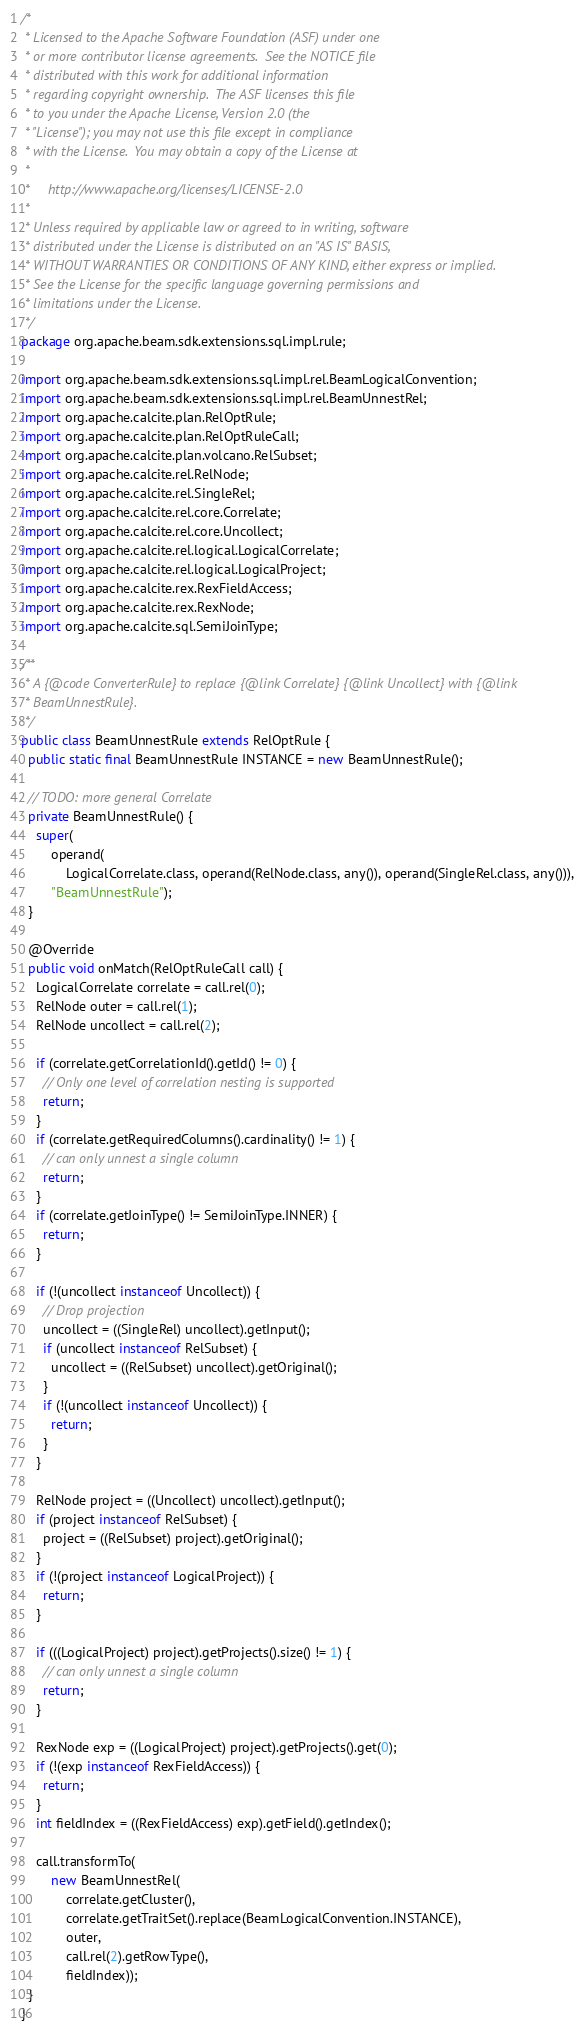<code> <loc_0><loc_0><loc_500><loc_500><_Java_>/*
 * Licensed to the Apache Software Foundation (ASF) under one
 * or more contributor license agreements.  See the NOTICE file
 * distributed with this work for additional information
 * regarding copyright ownership.  The ASF licenses this file
 * to you under the Apache License, Version 2.0 (the
 * "License"); you may not use this file except in compliance
 * with the License.  You may obtain a copy of the License at
 *
 *     http://www.apache.org/licenses/LICENSE-2.0
 *
 * Unless required by applicable law or agreed to in writing, software
 * distributed under the License is distributed on an "AS IS" BASIS,
 * WITHOUT WARRANTIES OR CONDITIONS OF ANY KIND, either express or implied.
 * See the License for the specific language governing permissions and
 * limitations under the License.
 */
package org.apache.beam.sdk.extensions.sql.impl.rule;

import org.apache.beam.sdk.extensions.sql.impl.rel.BeamLogicalConvention;
import org.apache.beam.sdk.extensions.sql.impl.rel.BeamUnnestRel;
import org.apache.calcite.plan.RelOptRule;
import org.apache.calcite.plan.RelOptRuleCall;
import org.apache.calcite.plan.volcano.RelSubset;
import org.apache.calcite.rel.RelNode;
import org.apache.calcite.rel.SingleRel;
import org.apache.calcite.rel.core.Correlate;
import org.apache.calcite.rel.core.Uncollect;
import org.apache.calcite.rel.logical.LogicalCorrelate;
import org.apache.calcite.rel.logical.LogicalProject;
import org.apache.calcite.rex.RexFieldAccess;
import org.apache.calcite.rex.RexNode;
import org.apache.calcite.sql.SemiJoinType;

/**
 * A {@code ConverterRule} to replace {@link Correlate} {@link Uncollect} with {@link
 * BeamUnnestRule}.
 */
public class BeamUnnestRule extends RelOptRule {
  public static final BeamUnnestRule INSTANCE = new BeamUnnestRule();

  // TODO: more general Correlate
  private BeamUnnestRule() {
    super(
        operand(
            LogicalCorrelate.class, operand(RelNode.class, any()), operand(SingleRel.class, any())),
        "BeamUnnestRule");
  }

  @Override
  public void onMatch(RelOptRuleCall call) {
    LogicalCorrelate correlate = call.rel(0);
    RelNode outer = call.rel(1);
    RelNode uncollect = call.rel(2);

    if (correlate.getCorrelationId().getId() != 0) {
      // Only one level of correlation nesting is supported
      return;
    }
    if (correlate.getRequiredColumns().cardinality() != 1) {
      // can only unnest a single column
      return;
    }
    if (correlate.getJoinType() != SemiJoinType.INNER) {
      return;
    }

    if (!(uncollect instanceof Uncollect)) {
      // Drop projection
      uncollect = ((SingleRel) uncollect).getInput();
      if (uncollect instanceof RelSubset) {
        uncollect = ((RelSubset) uncollect).getOriginal();
      }
      if (!(uncollect instanceof Uncollect)) {
        return;
      }
    }

    RelNode project = ((Uncollect) uncollect).getInput();
    if (project instanceof RelSubset) {
      project = ((RelSubset) project).getOriginal();
    }
    if (!(project instanceof LogicalProject)) {
      return;
    }

    if (((LogicalProject) project).getProjects().size() != 1) {
      // can only unnest a single column
      return;
    }

    RexNode exp = ((LogicalProject) project).getProjects().get(0);
    if (!(exp instanceof RexFieldAccess)) {
      return;
    }
    int fieldIndex = ((RexFieldAccess) exp).getField().getIndex();

    call.transformTo(
        new BeamUnnestRel(
            correlate.getCluster(),
            correlate.getTraitSet().replace(BeamLogicalConvention.INSTANCE),
            outer,
            call.rel(2).getRowType(),
            fieldIndex));
  }
}
</code> 